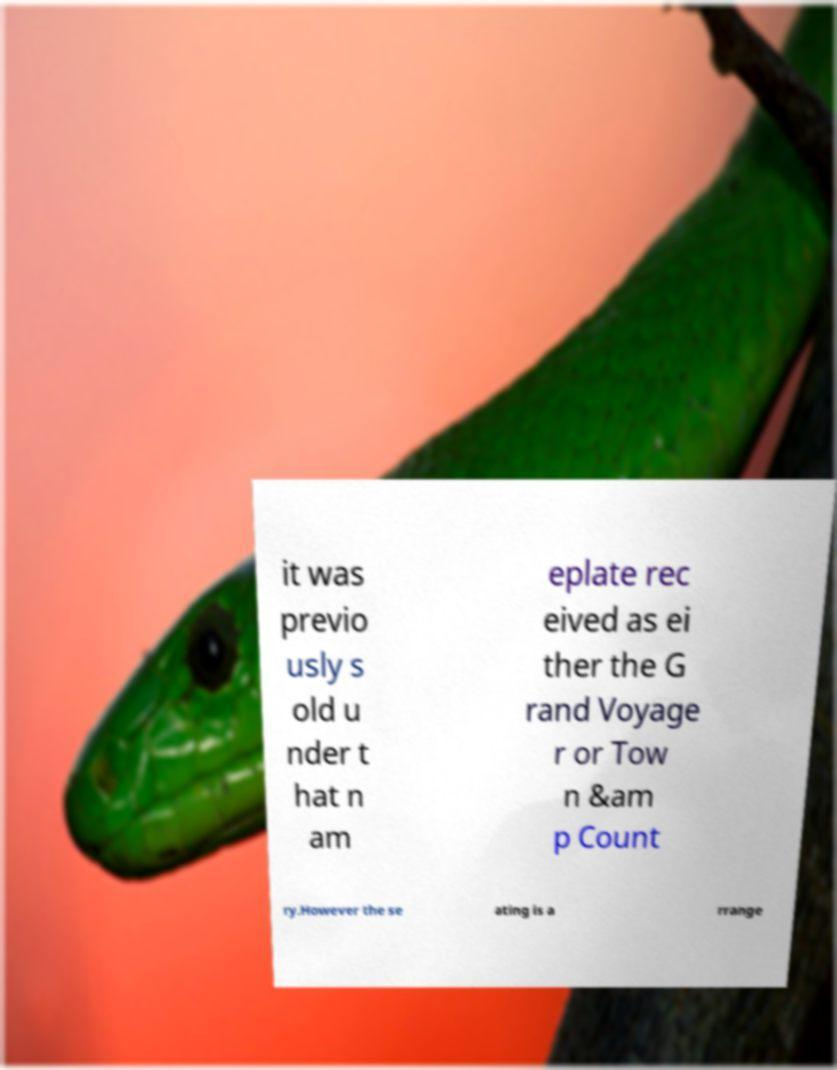Could you assist in decoding the text presented in this image and type it out clearly? it was previo usly s old u nder t hat n am eplate rec eived as ei ther the G rand Voyage r or Tow n &am p Count ry.However the se ating is a rrange 